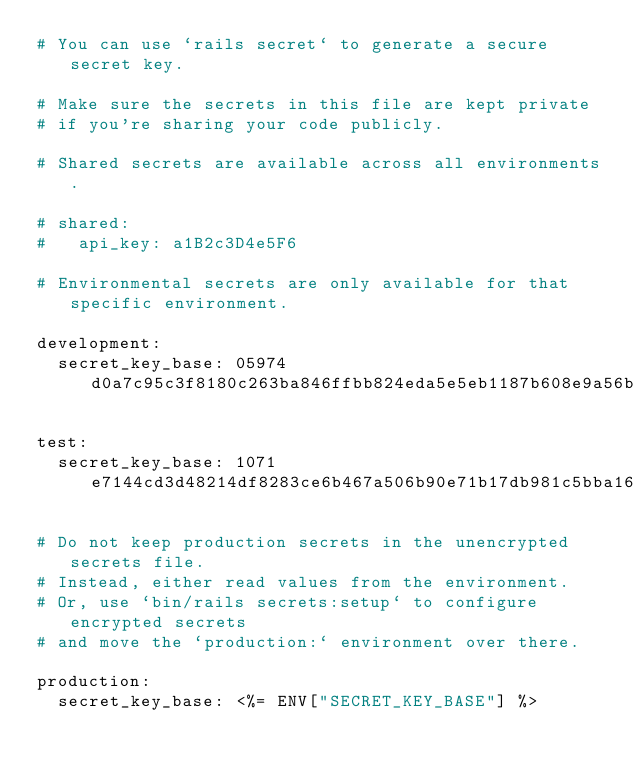Convert code to text. <code><loc_0><loc_0><loc_500><loc_500><_YAML_># You can use `rails secret` to generate a secure secret key.

# Make sure the secrets in this file are kept private
# if you're sharing your code publicly.

# Shared secrets are available across all environments.

# shared:
#   api_key: a1B2c3D4e5F6

# Environmental secrets are only available for that specific environment.

development:
  secret_key_base: 05974d0a7c95c3f8180c263ba846ffbb824eda5e5eb1187b608e9a56b4bbfcdda452f9b188920ecde15b5d53bc9145a547163ce85e70eb349f1f6c69c0ea9ef1

test:
  secret_key_base: 1071e7144cd3d48214df8283ce6b467a506b90e71b17db981c5bba1665745c71a6063b548c4e0aacb7265cdbcb6fb6e09e283976fee5bd1b1e9bd69b5ffadbc6

# Do not keep production secrets in the unencrypted secrets file.
# Instead, either read values from the environment.
# Or, use `bin/rails secrets:setup` to configure encrypted secrets
# and move the `production:` environment over there.

production:
  secret_key_base: <%= ENV["SECRET_KEY_BASE"] %>
</code> 